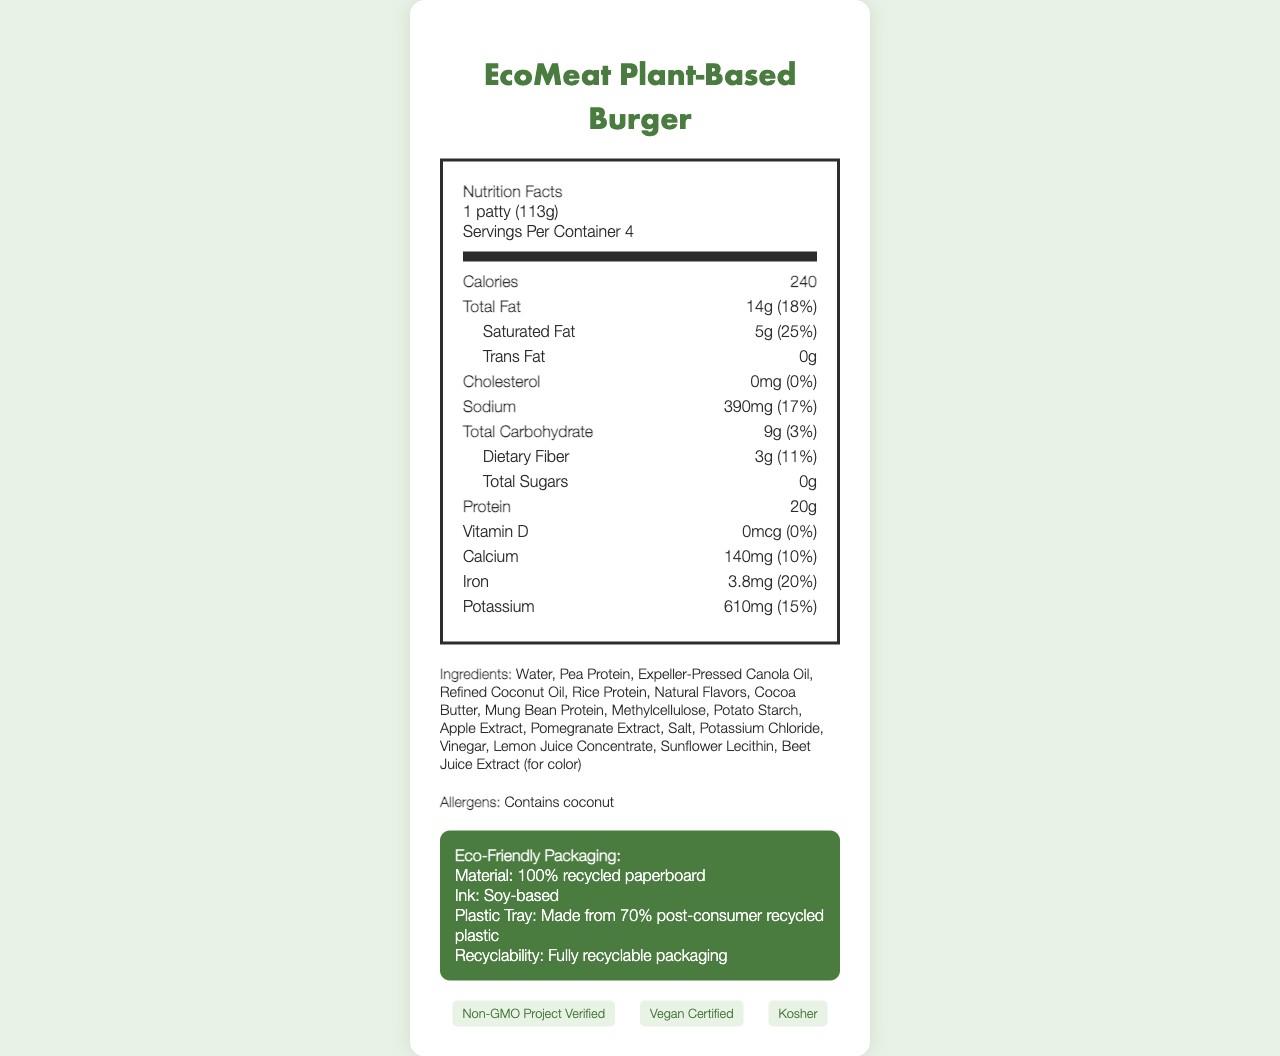What is the serving size for the EcoMeat Plant-Based Burger? The serving size is clearly indicated as 1 patty (113g) at the top of the nutrition facts label.
Answer: 1 patty (113g) How many servings are in one container of the EcoMeat Plant-Based Burger? The document specifies that there are 4 servings per container.
Answer: 4 What is the total amount of calories per serving? The nutrition facts label lists the calorie content per serving as 240 calories.
Answer: 240 How much protein does one patty contain? The amount of protein per serving is shown as 20 grams on the label.
Answer: 20g What percentage of the daily value of calcium does one serving provide? The label shows that one serving contains 140mg of calcium, which is 10% of the daily value.
Answer: 10% What are the primary ingredients listed for the EcoMeat Plant-Based Burger? The main ingredients listed at the top of the ingredients section are Water, Pea Protein, Expeller-Pressed Canola Oil, and Refined Coconut Oil.
Answer: Water, Pea Protein, Expeller-Pressed Canola Oil, Refined Coconut Oil Which of the following is NOT found in the EcoMeat Plant-Based Burger? A. Wheat B. Coconut C. Pea Protein The ingredients list includes Coconut and Pea Protein but does not include Wheat.
Answer: A. Wheat What type of ink is used in the eco-friendly packaging? The eco-friendly packaging section mentions that the ink used is Soy-based.
Answer: Soy-based Which of the following certifications does the EcoMeat Plant-Based Burger have? I. Non-GMO Project Verified II. Gluten-Free III. Vegan Certified The document lists the certifications as Non-GMO Project Verified, Vegan Certified, and Kosher, but not Gluten-Free.
Answer: I and III Does the document mention any allergens in the EcoMeat Plant-Based Burger? The allergens section specifically lists coconut as an allergen.
Answer: Yes Summarize the entire document. The document encompasses nutrition information, eco-friendly packaging data, ingredient lists, allergen warnings, and design features to convey a comprehensive view of the product's benefits and design aesthetics.
Answer: The document provides detailed nutrition facts, ingredients, allergen information, eco-friendly packaging details, and certifications for the EcoMeat Plant-Based Burger. The product is plant-based, high in protein, and eco-conscious, with minimalist design elements, such as a specific color scheme, typography, and iconography. What specific design elements are used in the document? The artistic details include a specific color scheme, typography choices, icons, and textures that reflect the brand's eco-friendly and minimalist approach.
Answer: Color Scheme (#4A7B3F, #E8F3E5, #2C2C2C), Typography (Futura Bold for brand name, Helvetica Neue Light for body text), Minimalist leaf icon, Recycling symbol, Water droplet, Subtle organic texture What is the percentage of daily value for total fat in one patty? The daily value for total fat per serving is listed as 18% on the nutrition facts label.
Answer: 18% How many grams of dietary fiber are in one serving? A. 3g B. 5g C. 8g D. 10g The label shows that each serving contains 3 grams of dietary fiber.
Answer: A. 3g What is the primary source of protein in the EcoMeat Plant-Based Burger? The document lists multiple sources of protein, including Pea Protein, Rice Protein, and Mung Bean Protein, without specifying which is the primary source.
Answer: Cannot be determined 